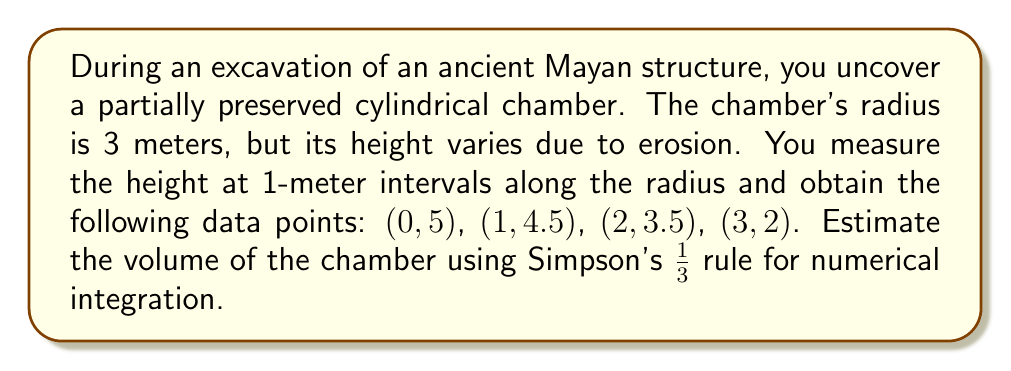Teach me how to tackle this problem. To estimate the volume of the partially excavated cylindrical chamber, we'll use Simpson's 1/3 rule for numerical integration. This method is particularly useful for approximating definite integrals and, in this case, the volume of a solid of revolution.

Step 1: Identify the function and interval
The height function $h(r)$ is defined by the given data points, where $r$ is the distance from the center of the chamber. The interval is $[0, 3]$ meters.

Step 2: Apply Simpson's 1/3 rule
The formula for Simpson's 1/3 rule is:

$$\int_a^b f(x)dx \approx \frac{h}{3}[f(x_0) + 4f(x_1) + 2f(x_2) + 4f(x_3) + ... + f(x_n)]$$

Where $h$ is the step size, and $n$ is the number of subintervals (must be even).

In our case, $h = 1$ meter, and we have 3 subintervals.

Step 3: Calculate the volume
For a solid of revolution, we integrate $\pi r^2 h(r)$ instead of just $h(r)$. So our integral becomes:

$$V = 2\pi \int_0^3 r h(r) dr$$

Applying Simpson's 1/3 rule:

$$V \approx \frac{2\pi}{3}[0 \cdot 5 + 4 \cdot 1 \cdot 4.5 + 2 \cdot 2 \cdot 3.5 + 3 \cdot 3 \cdot 2]$$

Step 4: Compute the result
$$V \approx \frac{2\pi}{3}[0 + 18 + 14 + 18]$$
$$V \approx \frac{2\pi}{3}[50]$$
$$V \approx 33.33\pi \approx 104.72 \text{ cubic meters}$$
Answer: $104.72 \text{ m}^3$ 